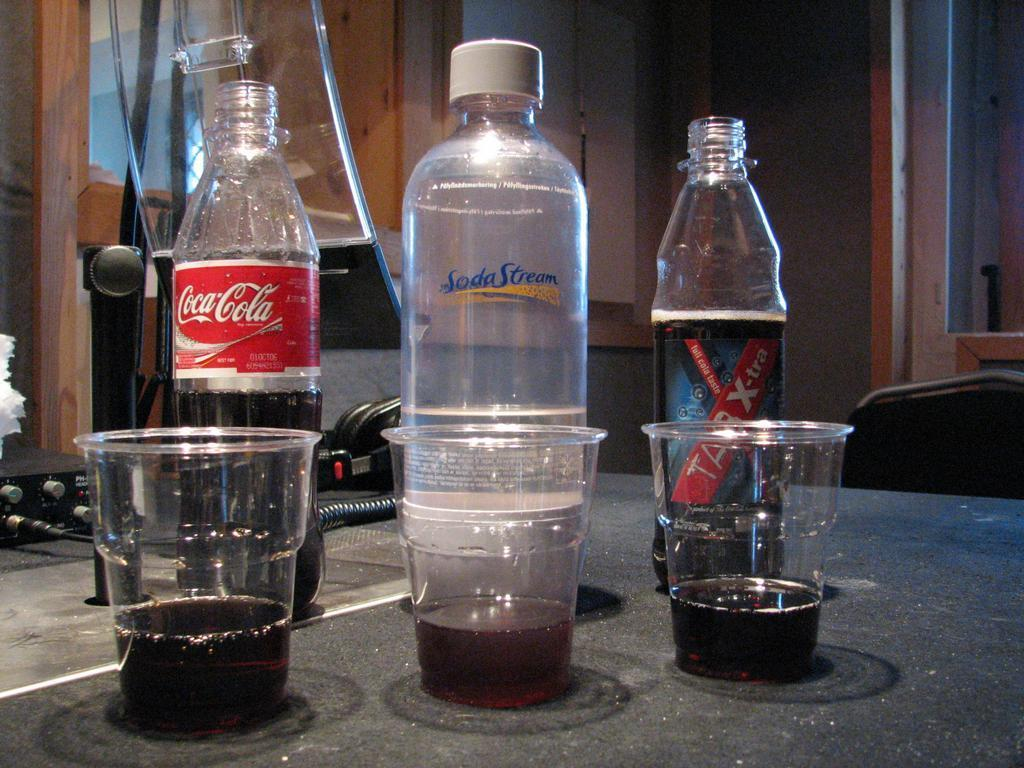How many bottles and cups are on the table in the image? There are three bottles and three cups on the table in the image. What can be seen in the background of the image? In the background, there is a mic, receivers, wires, and a wall. What might be used for connecting or transmitting sound in the image? The receivers and wires in the background might be used for connecting or transmitting sound. What type of quiver is hanging on the wall in the image? There is no quiver present in the image; it features bottles, cups, a mic, receivers, wires, and a wall. How many eyes can be seen on the wall in the image? There are no eyes visible on the wall in the image. 